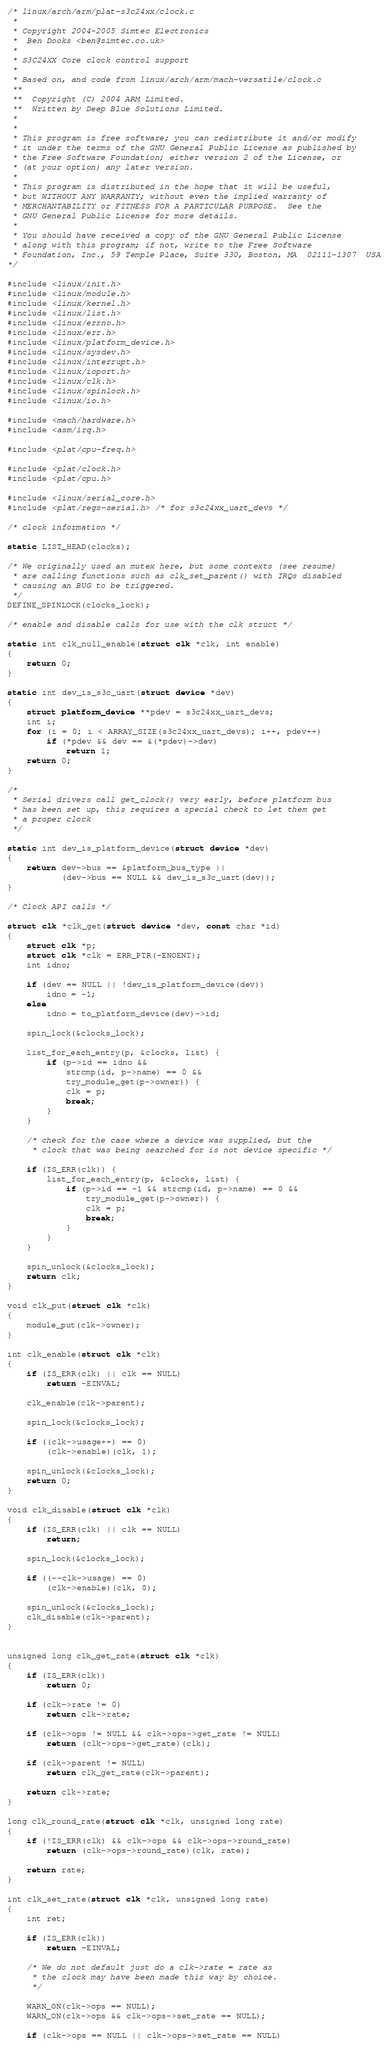Convert code to text. <code><loc_0><loc_0><loc_500><loc_500><_C_>/* linux/arch/arm/plat-s3c24xx/clock.c
 *
 * Copyright 2004-2005 Simtec Electronics
 *	Ben Dooks <ben@simtec.co.uk>
 *
 * S3C24XX Core clock control support
 *
 * Based on, and code from linux/arch/arm/mach-versatile/clock.c
 **
 **  Copyright (C) 2004 ARM Limited.
 **  Written by Deep Blue Solutions Limited.
 *
 *
 * This program is free software; you can redistribute it and/or modify
 * it under the terms of the GNU General Public License as published by
 * the Free Software Foundation; either version 2 of the License, or
 * (at your option) any later version.
 *
 * This program is distributed in the hope that it will be useful,
 * but WITHOUT ANY WARRANTY; without even the implied warranty of
 * MERCHANTABILITY or FITNESS FOR A PARTICULAR PURPOSE.  See the
 * GNU General Public License for more details.
 *
 * You should have received a copy of the GNU General Public License
 * along with this program; if not, write to the Free Software
 * Foundation, Inc., 59 Temple Place, Suite 330, Boston, MA  02111-1307  USA
*/

#include <linux/init.h>
#include <linux/module.h>
#include <linux/kernel.h>
#include <linux/list.h>
#include <linux/errno.h>
#include <linux/err.h>
#include <linux/platform_device.h>
#include <linux/sysdev.h>
#include <linux/interrupt.h>
#include <linux/ioport.h>
#include <linux/clk.h>
#include <linux/spinlock.h>
#include <linux/io.h>

#include <mach/hardware.h>
#include <asm/irq.h>

#include <plat/cpu-freq.h>

#include <plat/clock.h>
#include <plat/cpu.h>

#include <linux/serial_core.h>
#include <plat/regs-serial.h> /* for s3c24xx_uart_devs */

/* clock information */

static LIST_HEAD(clocks);

/* We originally used an mutex here, but some contexts (see resume)
 * are calling functions such as clk_set_parent() with IRQs disabled
 * causing an BUG to be triggered.
 */
DEFINE_SPINLOCK(clocks_lock);

/* enable and disable calls for use with the clk struct */

static int clk_null_enable(struct clk *clk, int enable)
{
	return 0;
}

static int dev_is_s3c_uart(struct device *dev)
{
	struct platform_device **pdev = s3c24xx_uart_devs;
	int i;
	for (i = 0; i < ARRAY_SIZE(s3c24xx_uart_devs); i++, pdev++)
		if (*pdev && dev == &(*pdev)->dev)
			return 1;
	return 0;
}

/*
 * Serial drivers call get_clock() very early, before platform bus
 * has been set up, this requires a special check to let them get
 * a proper clock
 */

static int dev_is_platform_device(struct device *dev)
{
	return dev->bus == &platform_bus_type ||
	       (dev->bus == NULL && dev_is_s3c_uart(dev));
}

/* Clock API calls */

struct clk *clk_get(struct device *dev, const char *id)
{
	struct clk *p;
	struct clk *clk = ERR_PTR(-ENOENT);
	int idno;

	if (dev == NULL || !dev_is_platform_device(dev))
		idno = -1;
	else
		idno = to_platform_device(dev)->id;

	spin_lock(&clocks_lock);

	list_for_each_entry(p, &clocks, list) {
		if (p->id == idno &&
		    strcmp(id, p->name) == 0 &&
		    try_module_get(p->owner)) {
			clk = p;
			break;
		}
	}

	/* check for the case where a device was supplied, but the
	 * clock that was being searched for is not device specific */

	if (IS_ERR(clk)) {
		list_for_each_entry(p, &clocks, list) {
			if (p->id == -1 && strcmp(id, p->name) == 0 &&
			    try_module_get(p->owner)) {
				clk = p;
				break;
			}
		}
	}

	spin_unlock(&clocks_lock);
	return clk;
}

void clk_put(struct clk *clk)
{
	module_put(clk->owner);
}

int clk_enable(struct clk *clk)
{
	if (IS_ERR(clk) || clk == NULL)
		return -EINVAL;

	clk_enable(clk->parent);

	spin_lock(&clocks_lock);

	if ((clk->usage++) == 0)
		(clk->enable)(clk, 1);

	spin_unlock(&clocks_lock);
	return 0;
}

void clk_disable(struct clk *clk)
{
	if (IS_ERR(clk) || clk == NULL)
		return;

	spin_lock(&clocks_lock);

	if ((--clk->usage) == 0)
		(clk->enable)(clk, 0);

	spin_unlock(&clocks_lock);
	clk_disable(clk->parent);
}


unsigned long clk_get_rate(struct clk *clk)
{
	if (IS_ERR(clk))
		return 0;

	if (clk->rate != 0)
		return clk->rate;

	if (clk->ops != NULL && clk->ops->get_rate != NULL)
		return (clk->ops->get_rate)(clk);

	if (clk->parent != NULL)
		return clk_get_rate(clk->parent);

	return clk->rate;
}

long clk_round_rate(struct clk *clk, unsigned long rate)
{
	if (!IS_ERR(clk) && clk->ops && clk->ops->round_rate)
		return (clk->ops->round_rate)(clk, rate);

	return rate;
}

int clk_set_rate(struct clk *clk, unsigned long rate)
{
	int ret;

	if (IS_ERR(clk))
		return -EINVAL;

	/* We do not default just do a clk->rate = rate as
	 * the clock may have been made this way by choice.
	 */

	WARN_ON(clk->ops == NULL);
	WARN_ON(clk->ops && clk->ops->set_rate == NULL);

	if (clk->ops == NULL || clk->ops->set_rate == NULL)</code> 